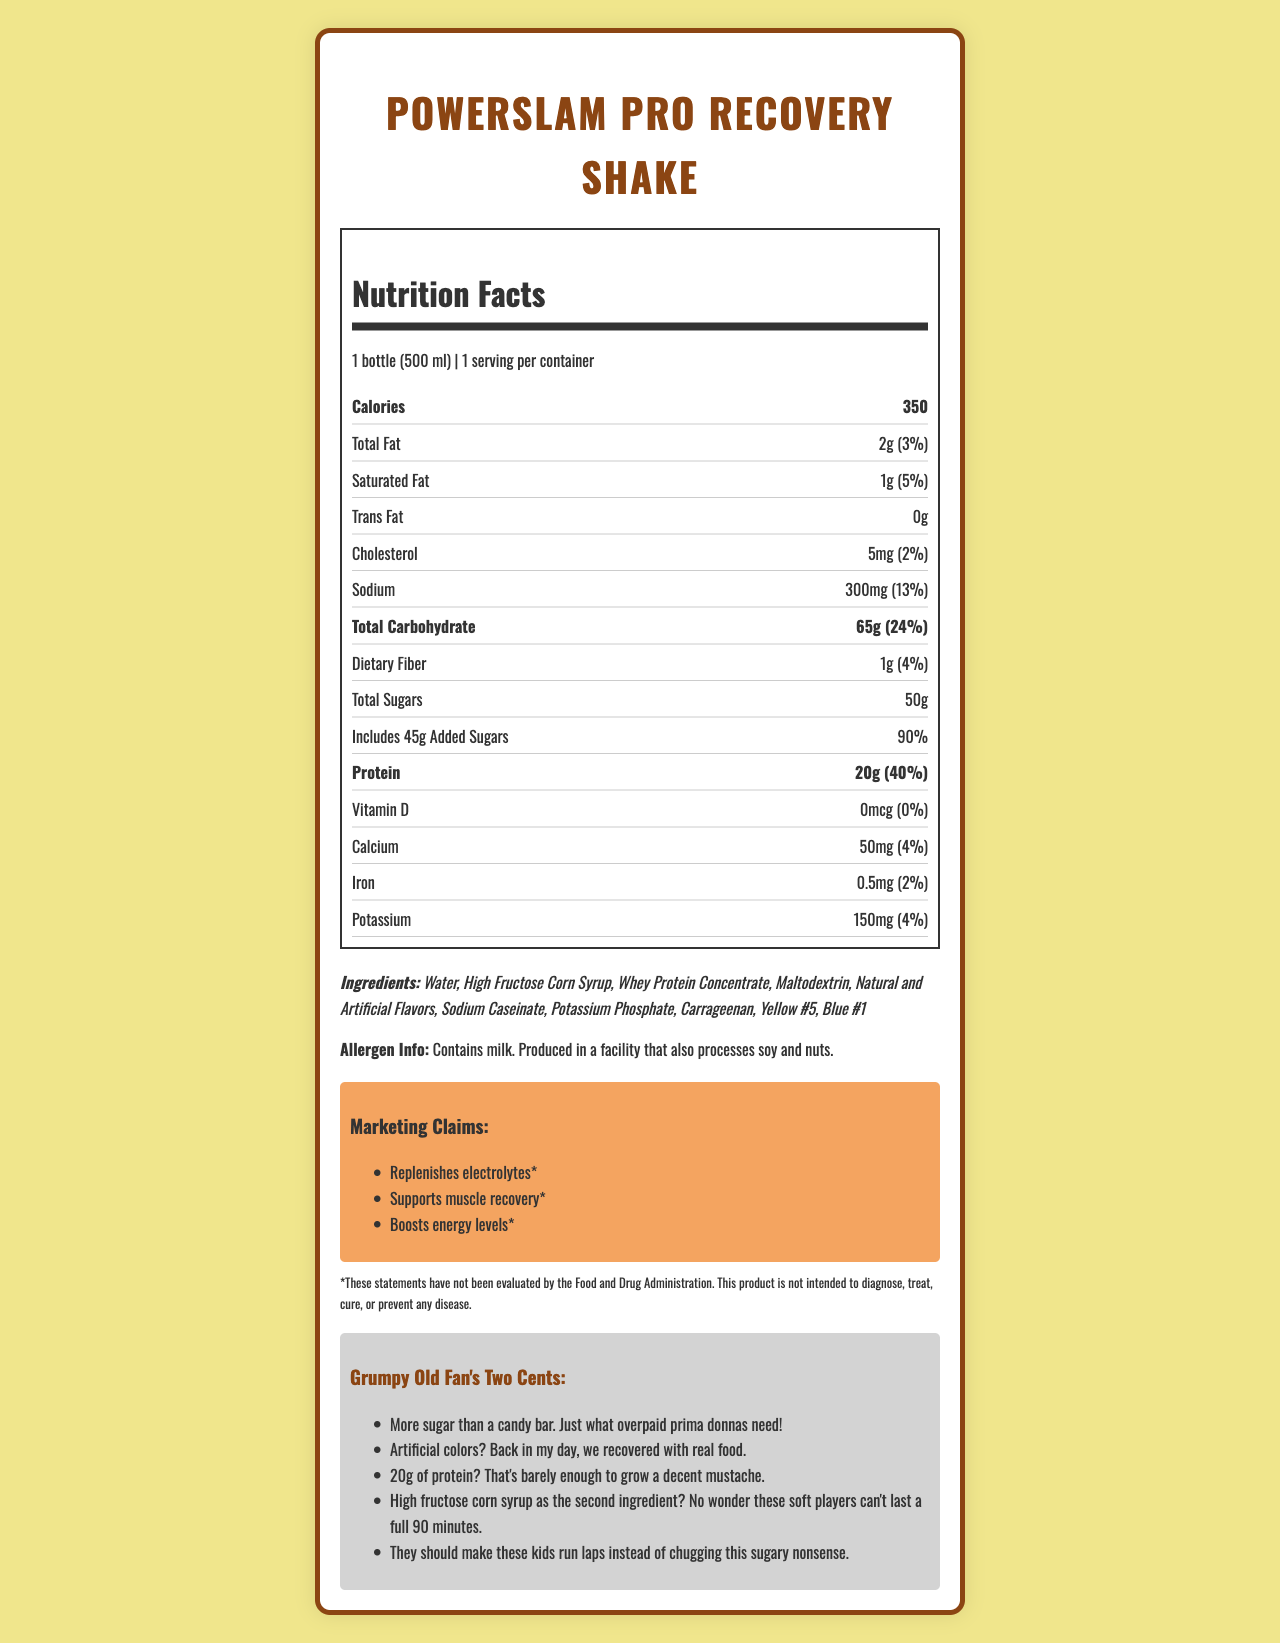What is the serving size of the PowerSlam Pro Recovery Shake? The document states the serving size as "1 bottle (500 ml)".
Answer: 1 bottle (500 ml) How many calories are in one bottle of the recovery shake? The nutrition label lists the calories as 350.
Answer: 350 How much total sugar does the shake contain? The amount of total sugars is listed as "50g".
Answer: 50g What percentage of the daily value is the added sugars? The document mentions "45g Added Sugars," which amounts to 90% of the daily value.
Answer: 90% Which ingredient is listed first in the ingredients list? The first ingredient mentioned in the list is "Water".
Answer: Water What is the amount of protein per serving? The nutrition facts state that there are 20g of protein per serving.
Answer: 20g Which of the following marketing claims is mentioned in the document? A. Reduces inflammation B. Supports muscle recovery C. Enhances mental focus The marketing claims list "Supports muscle recovery" as one of the claims.
Answer: B How much sodium is in one serving of PowerSlam Pro Recovery Shake? The document specifies that there are 300mg of sodium per serving.
Answer: 300mg Does the product contain any vitamin D? The document shows "0mcg" of Vitamin D with "0%" of the daily value.
Answer: No True or False: The product is intended to diagnose, treat, cure, or prevent any disease. The footnote clearly states that this product is "not intended to diagnose, treat, cure, or prevent any disease."
Answer: False Summarize the main nutritional concerns detailed in the document. The document raises concerns about the high sugar content (45g added sugars, 90% of daily value) and the inclusion of ingredients such as high fructose corn syrup and artificial colors.
Answer: High sugar content and questionable ingredients What is the daily value percentage for calcium in the shake? The document lists the daily value for calcium as 4%.
Answer: 4% Based on the document, is it clear if this shake is suitable for someone with a nut allergy? The label notes that the product is "produced in a facility that also processes soy and nuts," but it doesn't provide enough information to determine safety for individuals with nut allergies.
Answer: No, not enough information What color additives are used in this product? A. Red #40 and Yellow #6 B. Yellow #5 and Blue #1 C. Green #3 and Orange B The ingredient list includes "Yellow #5" and "Blue #1".
Answer: B What is a cynical comment on the amount of protein in the shake? This comment is one of the cynical remarks listed under the "Grumpy Old Fan's Two Cents" section.
Answer: 20g of protein? That's barely enough to grow a decent mustache. 